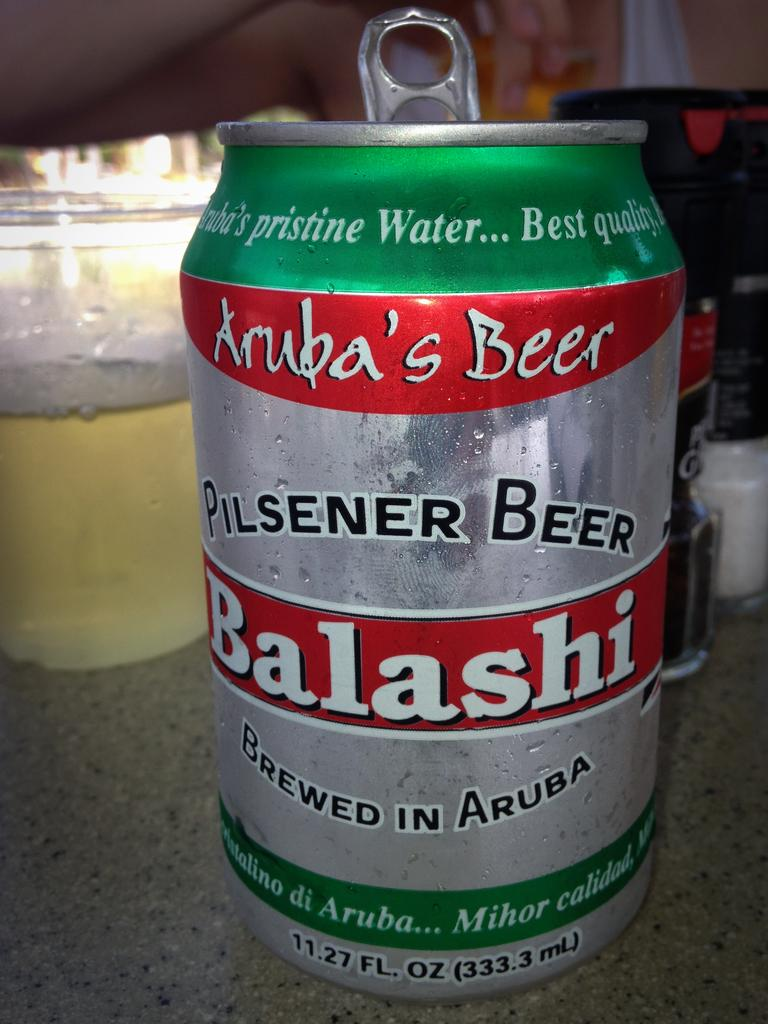<image>
Give a short and clear explanation of the subsequent image. a Balashi beer is next to a jar 